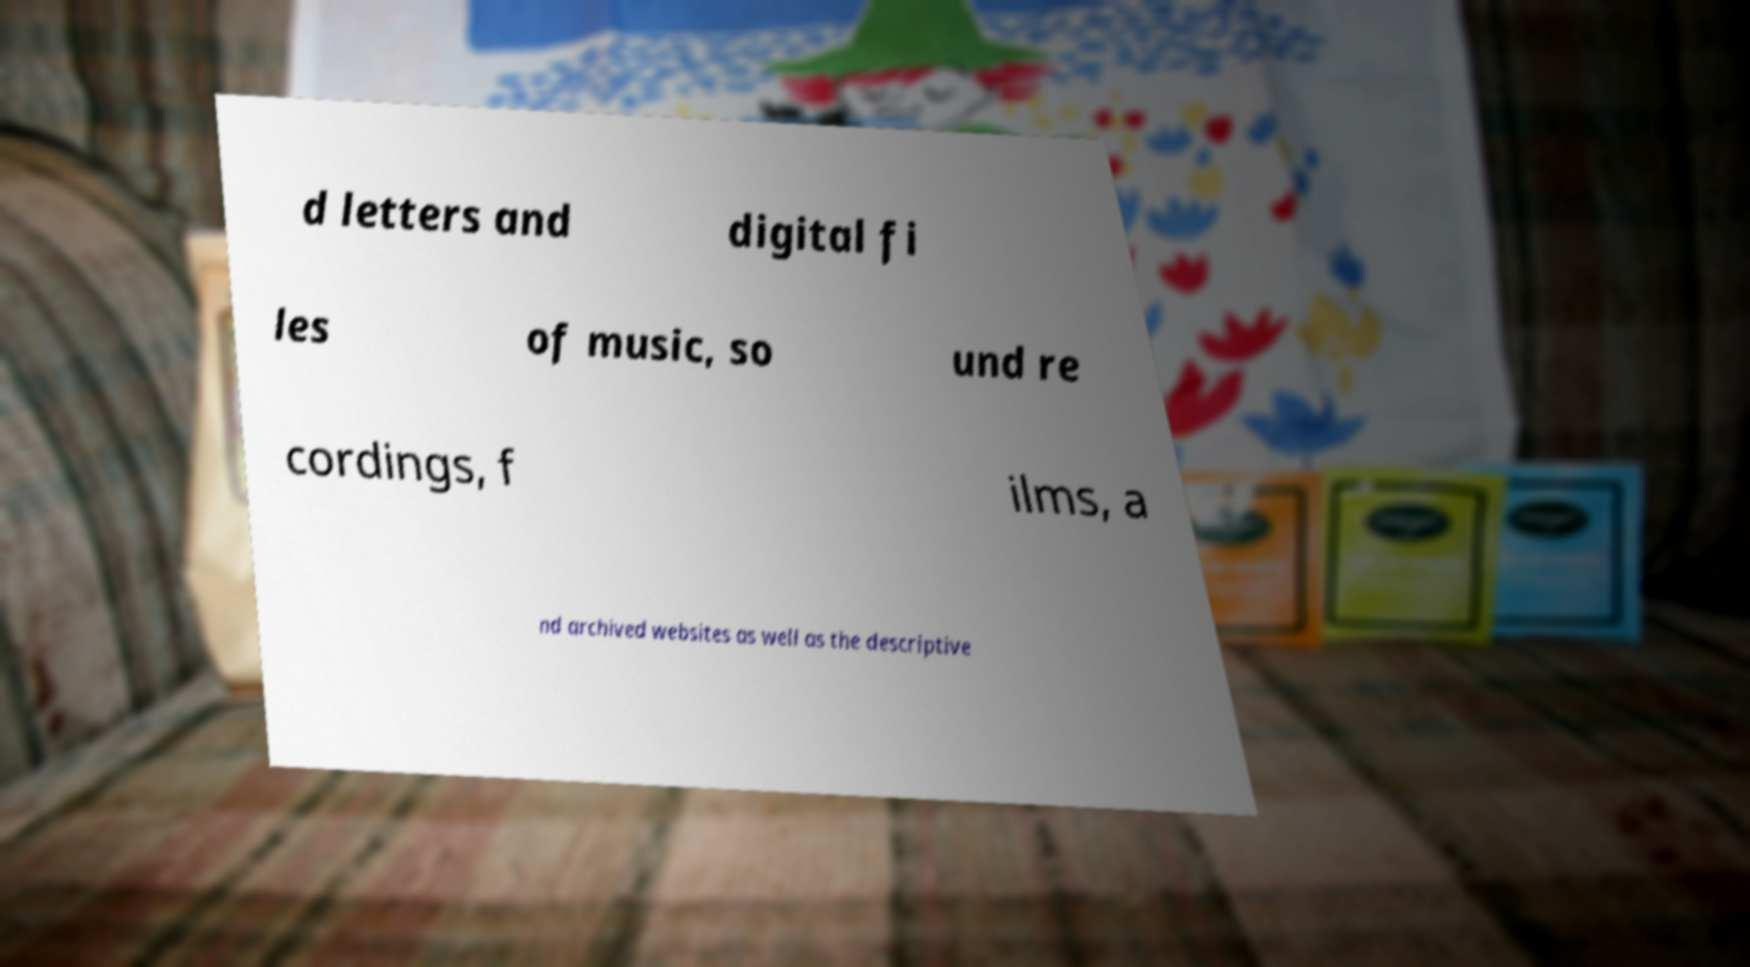Can you read and provide the text displayed in the image?This photo seems to have some interesting text. Can you extract and type it out for me? d letters and digital fi les of music, so und re cordings, f ilms, a nd archived websites as well as the descriptive 